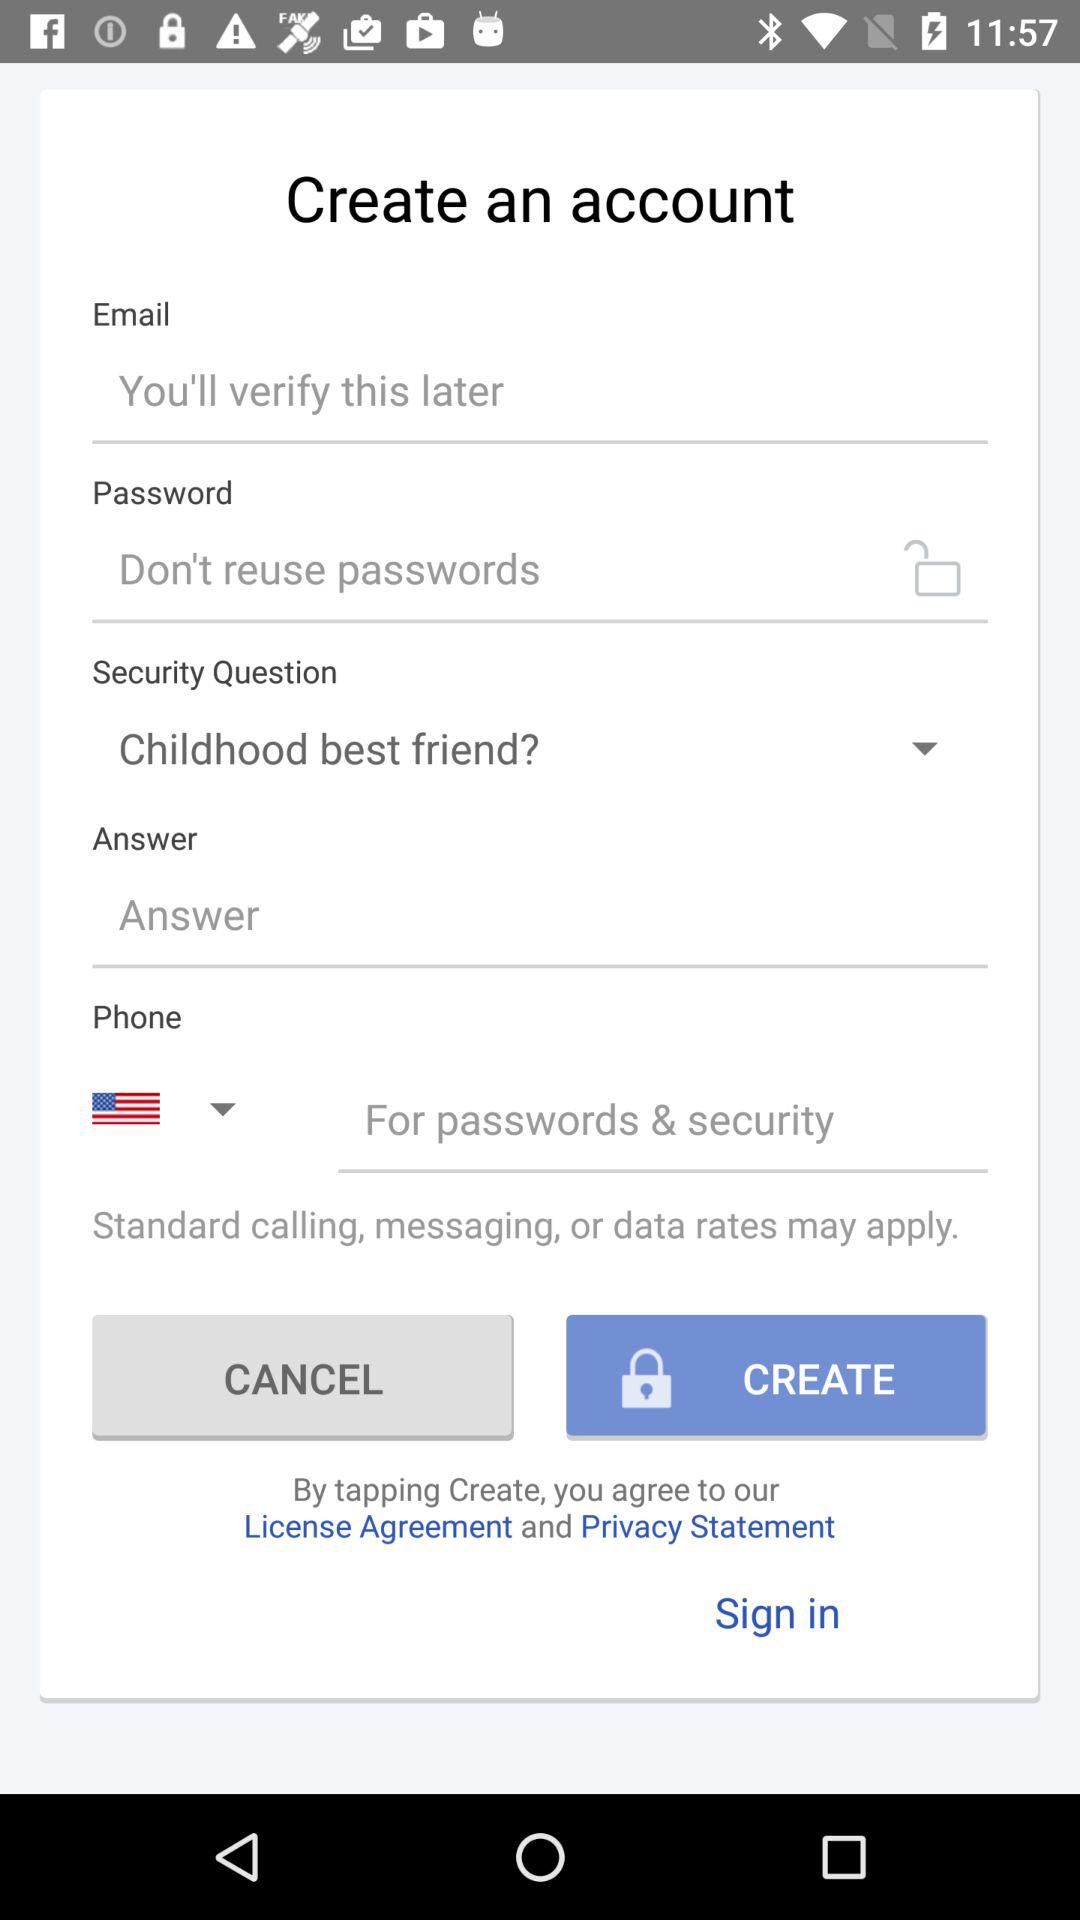How many security questions are on this page?
Answer the question using a single word or phrase. 1 